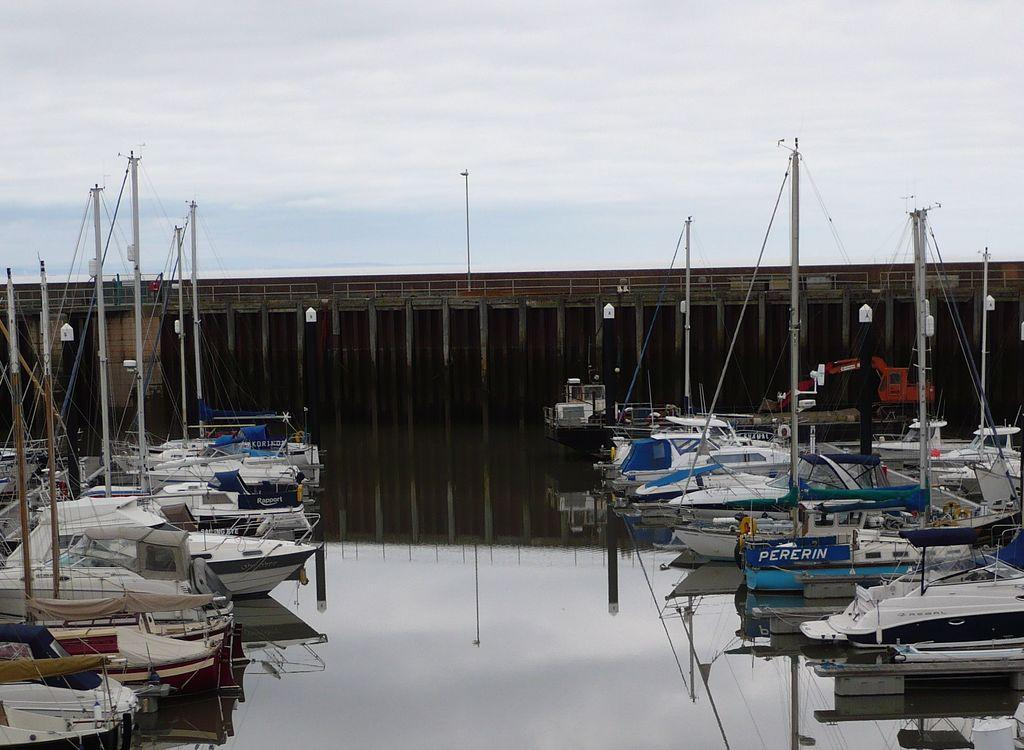What type of vehicles can be seen in the image? There are ships in the image. What structure is visible in the background of the image? There is a bridge in the background of the image. What object is present in the image that is not a ship or bridge? There is a pole in the image. What is visible at the top of the image? The sky is visible at the top of the image. How many pizzas are hanging from the pole in the image? There are no pizzas present in the image; it features ships, a bridge, and a pole. What type of ring can be seen on the ships in the image? There is no ring visible on the ships in the image. 